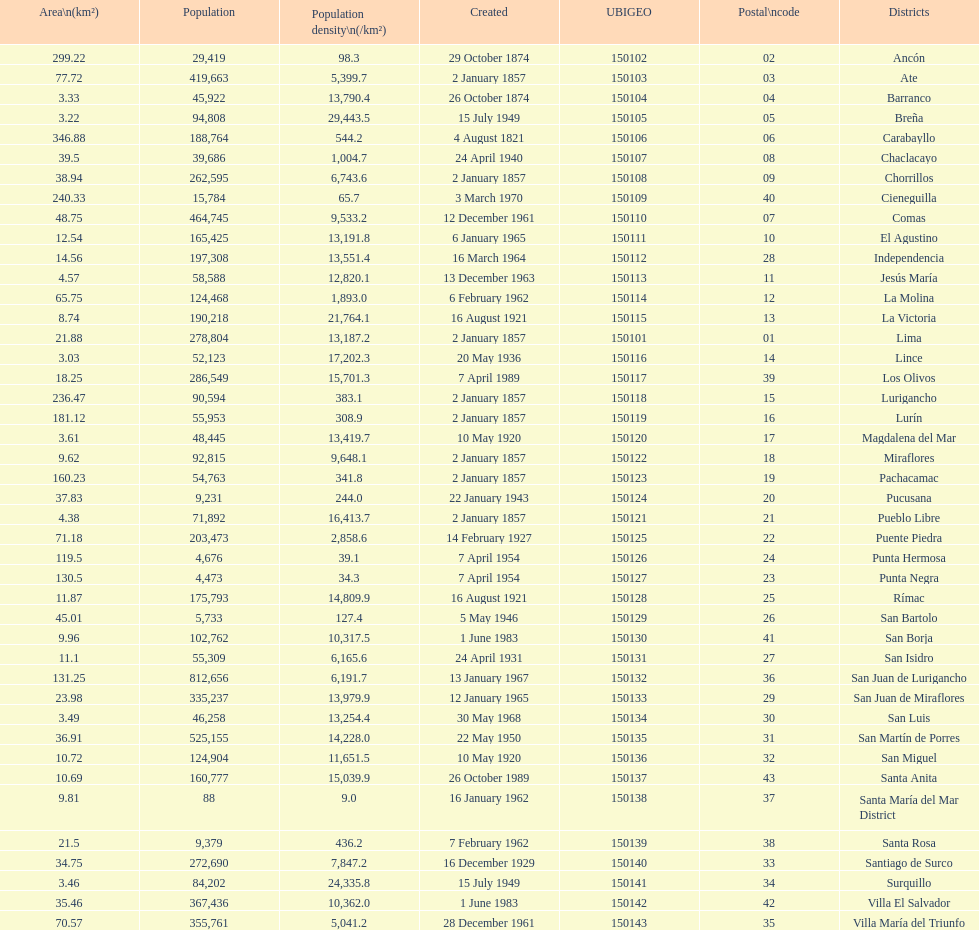What is the total number of districts created in the 1900's? 32. 